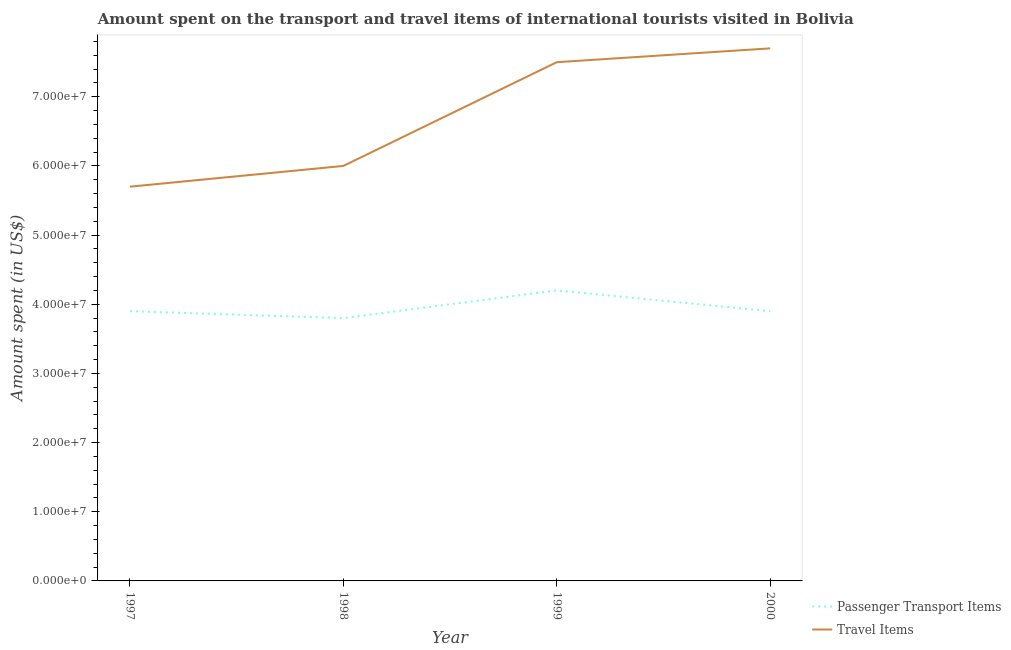How many different coloured lines are there?
Your answer should be very brief. 2. Is the number of lines equal to the number of legend labels?
Your answer should be compact. Yes. What is the amount spent on passenger transport items in 2000?
Provide a short and direct response. 3.90e+07. Across all years, what is the maximum amount spent on passenger transport items?
Offer a terse response. 4.20e+07. Across all years, what is the minimum amount spent on passenger transport items?
Provide a short and direct response. 3.80e+07. In which year was the amount spent in travel items minimum?
Make the answer very short. 1997. What is the total amount spent on passenger transport items in the graph?
Provide a short and direct response. 1.58e+08. What is the difference between the amount spent on passenger transport items in 1998 and that in 2000?
Offer a terse response. -1.00e+06. What is the difference between the amount spent in travel items in 1997 and the amount spent on passenger transport items in 2000?
Offer a very short reply. 1.80e+07. What is the average amount spent on passenger transport items per year?
Offer a terse response. 3.95e+07. In the year 2000, what is the difference between the amount spent in travel items and amount spent on passenger transport items?
Provide a succinct answer. 3.80e+07. In how many years, is the amount spent on passenger transport items greater than 18000000 US$?
Ensure brevity in your answer.  4. What is the ratio of the amount spent on passenger transport items in 1998 to that in 1999?
Keep it short and to the point. 0.9. Is the amount spent in travel items in 1997 less than that in 1999?
Your answer should be compact. Yes. Is the difference between the amount spent in travel items in 1998 and 2000 greater than the difference between the amount spent on passenger transport items in 1998 and 2000?
Keep it short and to the point. No. What is the difference between the highest and the second highest amount spent on passenger transport items?
Offer a very short reply. 3.00e+06. What is the difference between the highest and the lowest amount spent in travel items?
Your answer should be compact. 2.00e+07. Does the amount spent in travel items monotonically increase over the years?
Your answer should be very brief. Yes. Is the amount spent in travel items strictly greater than the amount spent on passenger transport items over the years?
Your answer should be very brief. Yes. Are the values on the major ticks of Y-axis written in scientific E-notation?
Your answer should be compact. Yes. Does the graph contain any zero values?
Give a very brief answer. No. Does the graph contain grids?
Give a very brief answer. No. How are the legend labels stacked?
Make the answer very short. Vertical. What is the title of the graph?
Your answer should be compact. Amount spent on the transport and travel items of international tourists visited in Bolivia. What is the label or title of the X-axis?
Your response must be concise. Year. What is the label or title of the Y-axis?
Your answer should be very brief. Amount spent (in US$). What is the Amount spent (in US$) in Passenger Transport Items in 1997?
Keep it short and to the point. 3.90e+07. What is the Amount spent (in US$) of Travel Items in 1997?
Keep it short and to the point. 5.70e+07. What is the Amount spent (in US$) of Passenger Transport Items in 1998?
Your response must be concise. 3.80e+07. What is the Amount spent (in US$) of Travel Items in 1998?
Your answer should be compact. 6.00e+07. What is the Amount spent (in US$) of Passenger Transport Items in 1999?
Your answer should be compact. 4.20e+07. What is the Amount spent (in US$) in Travel Items in 1999?
Give a very brief answer. 7.50e+07. What is the Amount spent (in US$) in Passenger Transport Items in 2000?
Offer a very short reply. 3.90e+07. What is the Amount spent (in US$) of Travel Items in 2000?
Ensure brevity in your answer.  7.70e+07. Across all years, what is the maximum Amount spent (in US$) in Passenger Transport Items?
Provide a succinct answer. 4.20e+07. Across all years, what is the maximum Amount spent (in US$) of Travel Items?
Make the answer very short. 7.70e+07. Across all years, what is the minimum Amount spent (in US$) of Passenger Transport Items?
Provide a succinct answer. 3.80e+07. Across all years, what is the minimum Amount spent (in US$) in Travel Items?
Make the answer very short. 5.70e+07. What is the total Amount spent (in US$) of Passenger Transport Items in the graph?
Give a very brief answer. 1.58e+08. What is the total Amount spent (in US$) of Travel Items in the graph?
Offer a very short reply. 2.69e+08. What is the difference between the Amount spent (in US$) in Passenger Transport Items in 1997 and that in 1998?
Provide a short and direct response. 1.00e+06. What is the difference between the Amount spent (in US$) of Passenger Transport Items in 1997 and that in 1999?
Offer a very short reply. -3.00e+06. What is the difference between the Amount spent (in US$) in Travel Items in 1997 and that in 1999?
Provide a succinct answer. -1.80e+07. What is the difference between the Amount spent (in US$) of Travel Items in 1997 and that in 2000?
Provide a short and direct response. -2.00e+07. What is the difference between the Amount spent (in US$) in Travel Items in 1998 and that in 1999?
Make the answer very short. -1.50e+07. What is the difference between the Amount spent (in US$) of Travel Items in 1998 and that in 2000?
Your answer should be compact. -1.70e+07. What is the difference between the Amount spent (in US$) in Passenger Transport Items in 1999 and that in 2000?
Give a very brief answer. 3.00e+06. What is the difference between the Amount spent (in US$) of Travel Items in 1999 and that in 2000?
Give a very brief answer. -2.00e+06. What is the difference between the Amount spent (in US$) in Passenger Transport Items in 1997 and the Amount spent (in US$) in Travel Items in 1998?
Your response must be concise. -2.10e+07. What is the difference between the Amount spent (in US$) of Passenger Transport Items in 1997 and the Amount spent (in US$) of Travel Items in 1999?
Provide a short and direct response. -3.60e+07. What is the difference between the Amount spent (in US$) of Passenger Transport Items in 1997 and the Amount spent (in US$) of Travel Items in 2000?
Provide a short and direct response. -3.80e+07. What is the difference between the Amount spent (in US$) in Passenger Transport Items in 1998 and the Amount spent (in US$) in Travel Items in 1999?
Your response must be concise. -3.70e+07. What is the difference between the Amount spent (in US$) in Passenger Transport Items in 1998 and the Amount spent (in US$) in Travel Items in 2000?
Make the answer very short. -3.90e+07. What is the difference between the Amount spent (in US$) of Passenger Transport Items in 1999 and the Amount spent (in US$) of Travel Items in 2000?
Offer a very short reply. -3.50e+07. What is the average Amount spent (in US$) in Passenger Transport Items per year?
Provide a succinct answer. 3.95e+07. What is the average Amount spent (in US$) in Travel Items per year?
Provide a short and direct response. 6.72e+07. In the year 1997, what is the difference between the Amount spent (in US$) in Passenger Transport Items and Amount spent (in US$) in Travel Items?
Give a very brief answer. -1.80e+07. In the year 1998, what is the difference between the Amount spent (in US$) in Passenger Transport Items and Amount spent (in US$) in Travel Items?
Offer a very short reply. -2.20e+07. In the year 1999, what is the difference between the Amount spent (in US$) in Passenger Transport Items and Amount spent (in US$) in Travel Items?
Provide a succinct answer. -3.30e+07. In the year 2000, what is the difference between the Amount spent (in US$) of Passenger Transport Items and Amount spent (in US$) of Travel Items?
Provide a short and direct response. -3.80e+07. What is the ratio of the Amount spent (in US$) of Passenger Transport Items in 1997 to that in 1998?
Provide a short and direct response. 1.03. What is the ratio of the Amount spent (in US$) of Travel Items in 1997 to that in 1999?
Your answer should be very brief. 0.76. What is the ratio of the Amount spent (in US$) in Passenger Transport Items in 1997 to that in 2000?
Keep it short and to the point. 1. What is the ratio of the Amount spent (in US$) of Travel Items in 1997 to that in 2000?
Keep it short and to the point. 0.74. What is the ratio of the Amount spent (in US$) in Passenger Transport Items in 1998 to that in 1999?
Offer a very short reply. 0.9. What is the ratio of the Amount spent (in US$) of Passenger Transport Items in 1998 to that in 2000?
Keep it short and to the point. 0.97. What is the ratio of the Amount spent (in US$) of Travel Items in 1998 to that in 2000?
Your answer should be very brief. 0.78. What is the ratio of the Amount spent (in US$) of Travel Items in 1999 to that in 2000?
Provide a short and direct response. 0.97. What is the difference between the highest and the second highest Amount spent (in US$) in Passenger Transport Items?
Offer a very short reply. 3.00e+06. What is the difference between the highest and the second highest Amount spent (in US$) of Travel Items?
Your response must be concise. 2.00e+06. What is the difference between the highest and the lowest Amount spent (in US$) of Passenger Transport Items?
Your answer should be very brief. 4.00e+06. 